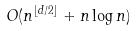Convert formula to latex. <formula><loc_0><loc_0><loc_500><loc_500>O ( n ^ { \lfloor d / 2 \rfloor } + n \log n )</formula> 